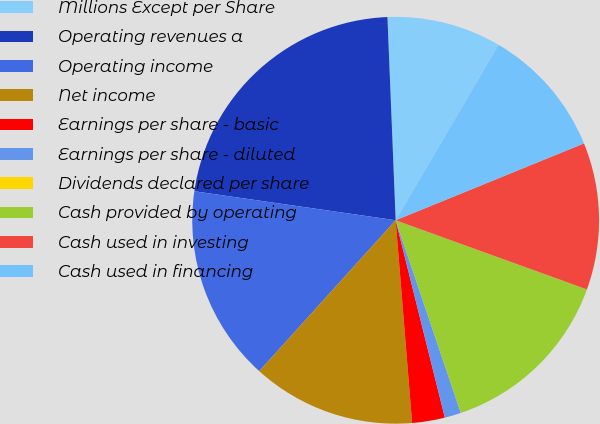<chart> <loc_0><loc_0><loc_500><loc_500><pie_chart><fcel>Millions Except per Share<fcel>Operating revenues a<fcel>Operating income<fcel>Net income<fcel>Earnings per share - basic<fcel>Earnings per share - diluted<fcel>Dividends declared per share<fcel>Cash provided by operating<fcel>Cash used in investing<fcel>Cash used in financing<nl><fcel>9.09%<fcel>22.08%<fcel>15.58%<fcel>12.99%<fcel>2.6%<fcel>1.3%<fcel>0.0%<fcel>14.29%<fcel>11.69%<fcel>10.39%<nl></chart> 